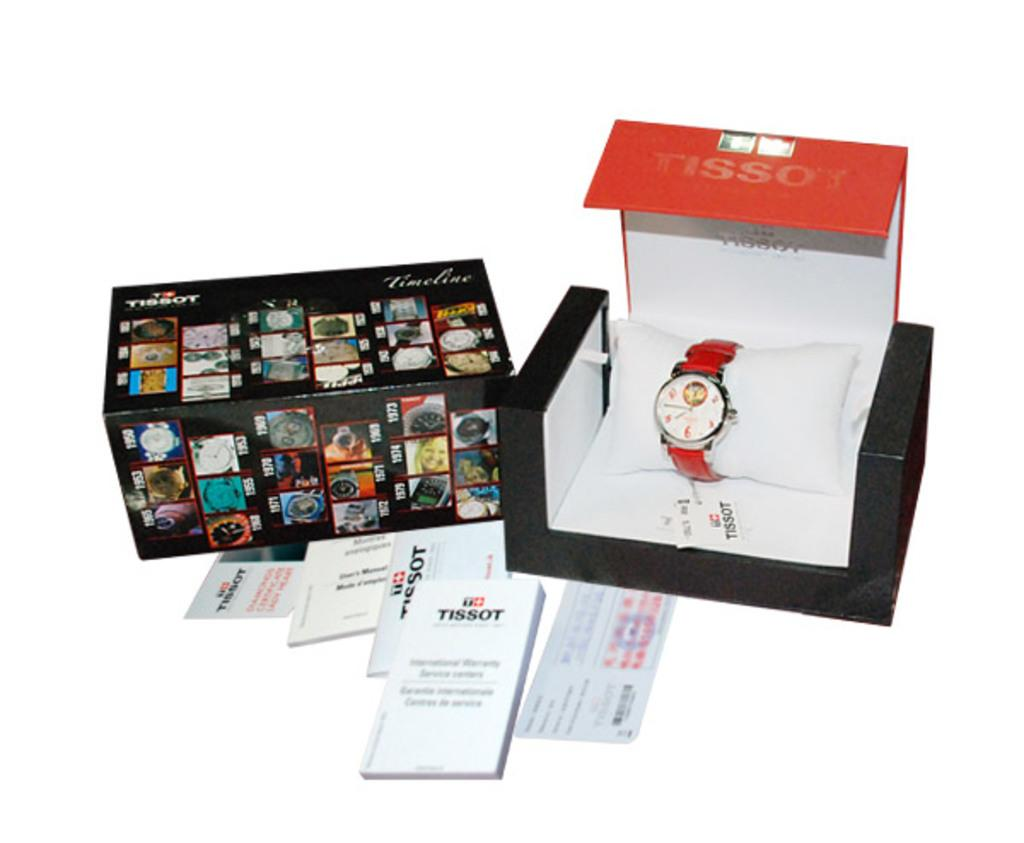<image>
Create a compact narrative representing the image presented. a box of a TISSOT watch with a red band. 